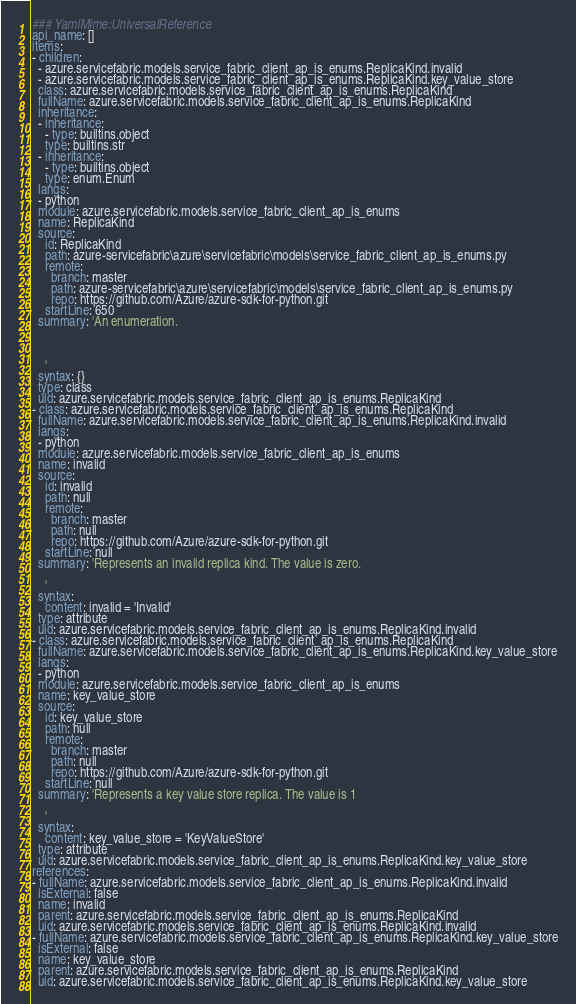Convert code to text. <code><loc_0><loc_0><loc_500><loc_500><_YAML_>### YamlMime:UniversalReference
api_name: []
items:
- children:
  - azure.servicefabric.models.service_fabric_client_ap_is_enums.ReplicaKind.invalid
  - azure.servicefabric.models.service_fabric_client_ap_is_enums.ReplicaKind.key_value_store
  class: azure.servicefabric.models.service_fabric_client_ap_is_enums.ReplicaKind
  fullName: azure.servicefabric.models.service_fabric_client_ap_is_enums.ReplicaKind
  inheritance:
  - inheritance:
    - type: builtins.object
    type: builtins.str
  - inheritance:
    - type: builtins.object
    type: enum.Enum
  langs:
  - python
  module: azure.servicefabric.models.service_fabric_client_ap_is_enums
  name: ReplicaKind
  source:
    id: ReplicaKind
    path: azure-servicefabric\azure\servicefabric\models\service_fabric_client_ap_is_enums.py
    remote:
      branch: master
      path: azure-servicefabric\azure\servicefabric\models\service_fabric_client_ap_is_enums.py
      repo: https://github.com/Azure/azure-sdk-for-python.git
    startLine: 650
  summary: 'An enumeration.



    '
  syntax: {}
  type: class
  uid: azure.servicefabric.models.service_fabric_client_ap_is_enums.ReplicaKind
- class: azure.servicefabric.models.service_fabric_client_ap_is_enums.ReplicaKind
  fullName: azure.servicefabric.models.service_fabric_client_ap_is_enums.ReplicaKind.invalid
  langs:
  - python
  module: azure.servicefabric.models.service_fabric_client_ap_is_enums
  name: invalid
  source:
    id: invalid
    path: null
    remote:
      branch: master
      path: null
      repo: https://github.com/Azure/azure-sdk-for-python.git
    startLine: null
  summary: 'Represents an invalid replica kind. The value is zero.

    '
  syntax:
    content: invalid = 'Invalid'
  type: attribute
  uid: azure.servicefabric.models.service_fabric_client_ap_is_enums.ReplicaKind.invalid
- class: azure.servicefabric.models.service_fabric_client_ap_is_enums.ReplicaKind
  fullName: azure.servicefabric.models.service_fabric_client_ap_is_enums.ReplicaKind.key_value_store
  langs:
  - python
  module: azure.servicefabric.models.service_fabric_client_ap_is_enums
  name: key_value_store
  source:
    id: key_value_store
    path: null
    remote:
      branch: master
      path: null
      repo: https://github.com/Azure/azure-sdk-for-python.git
    startLine: null
  summary: 'Represents a key value store replica. The value is 1

    '
  syntax:
    content: key_value_store = 'KeyValueStore'
  type: attribute
  uid: azure.servicefabric.models.service_fabric_client_ap_is_enums.ReplicaKind.key_value_store
references:
- fullName: azure.servicefabric.models.service_fabric_client_ap_is_enums.ReplicaKind.invalid
  isExternal: false
  name: invalid
  parent: azure.servicefabric.models.service_fabric_client_ap_is_enums.ReplicaKind
  uid: azure.servicefabric.models.service_fabric_client_ap_is_enums.ReplicaKind.invalid
- fullName: azure.servicefabric.models.service_fabric_client_ap_is_enums.ReplicaKind.key_value_store
  isExternal: false
  name: key_value_store
  parent: azure.servicefabric.models.service_fabric_client_ap_is_enums.ReplicaKind
  uid: azure.servicefabric.models.service_fabric_client_ap_is_enums.ReplicaKind.key_value_store
</code> 